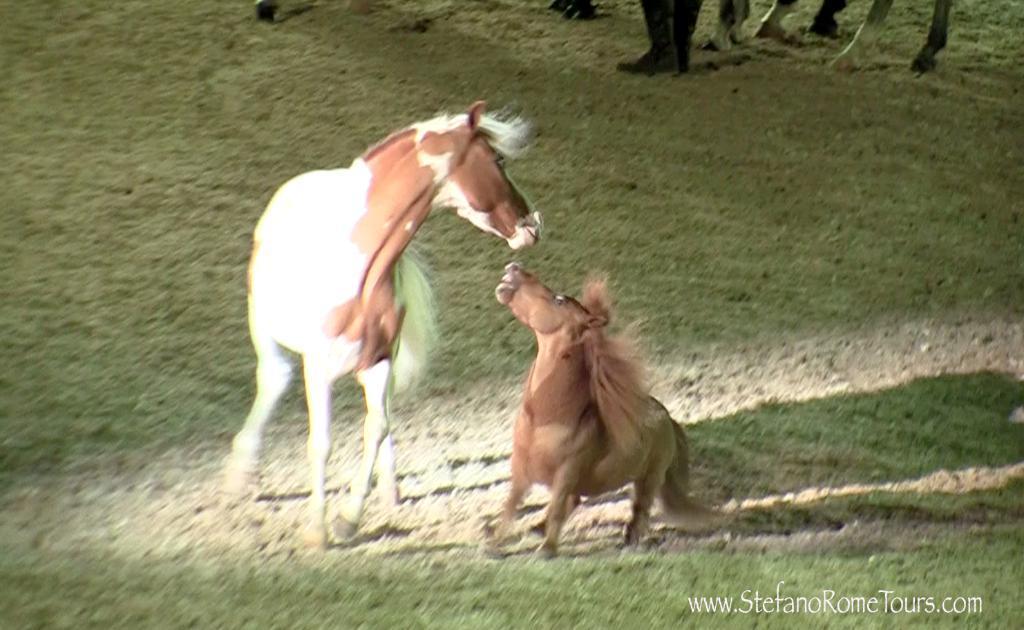What type of living organisms can be seen in the image? There are animals in the image. Where are the animals located? The animals are on the grass. Is there any text present in the image? Yes, there is text written on the right side at the bottom of the image. What is the animal's knee doing in the image? There is no specific mention of an animal's knee in the image, and therefore it cannot be determined what the knee is doing. 